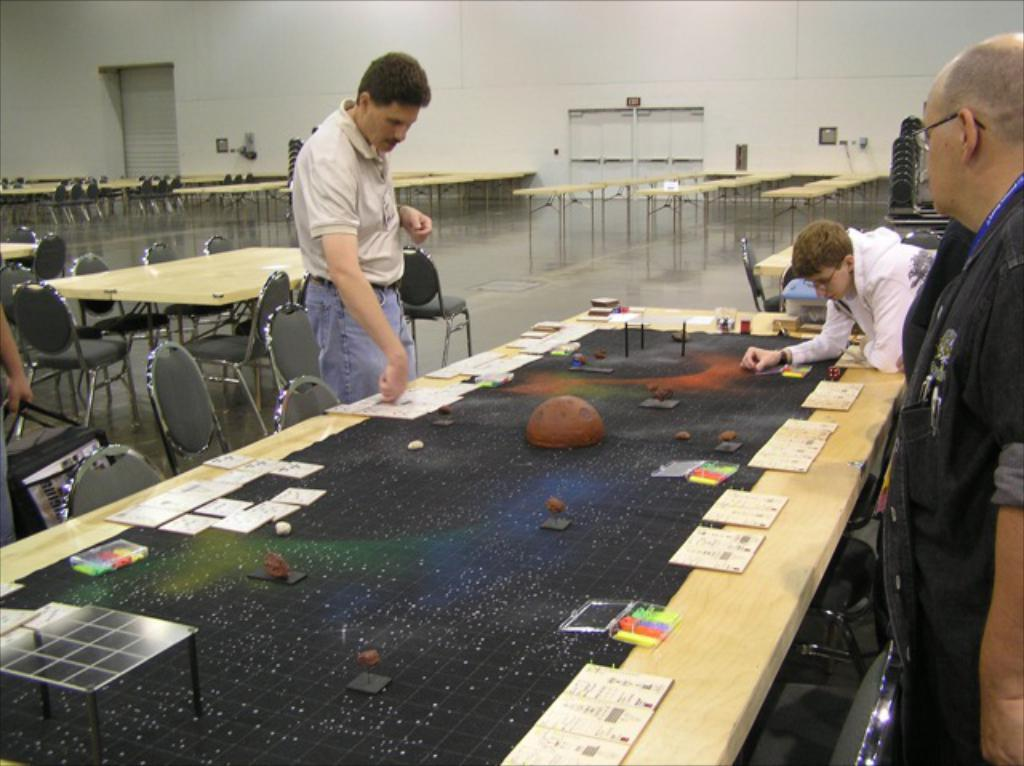How many men are in the image? There are three men in the image. What are the men doing in the image? The men are standing and playing on a table. What objects can be seen on the table? There are cards and boxes on the table. What can be seen in the background of the image? There is a wall, a door, tables, chairs, and shutters in the background of the image. What type of flock can be seen flying in the image? There is no flock of birds or animals visible in the image. How many times do the men cough in the image? The image does not show the men coughing, so it cannot be determined how many times they might cough. 